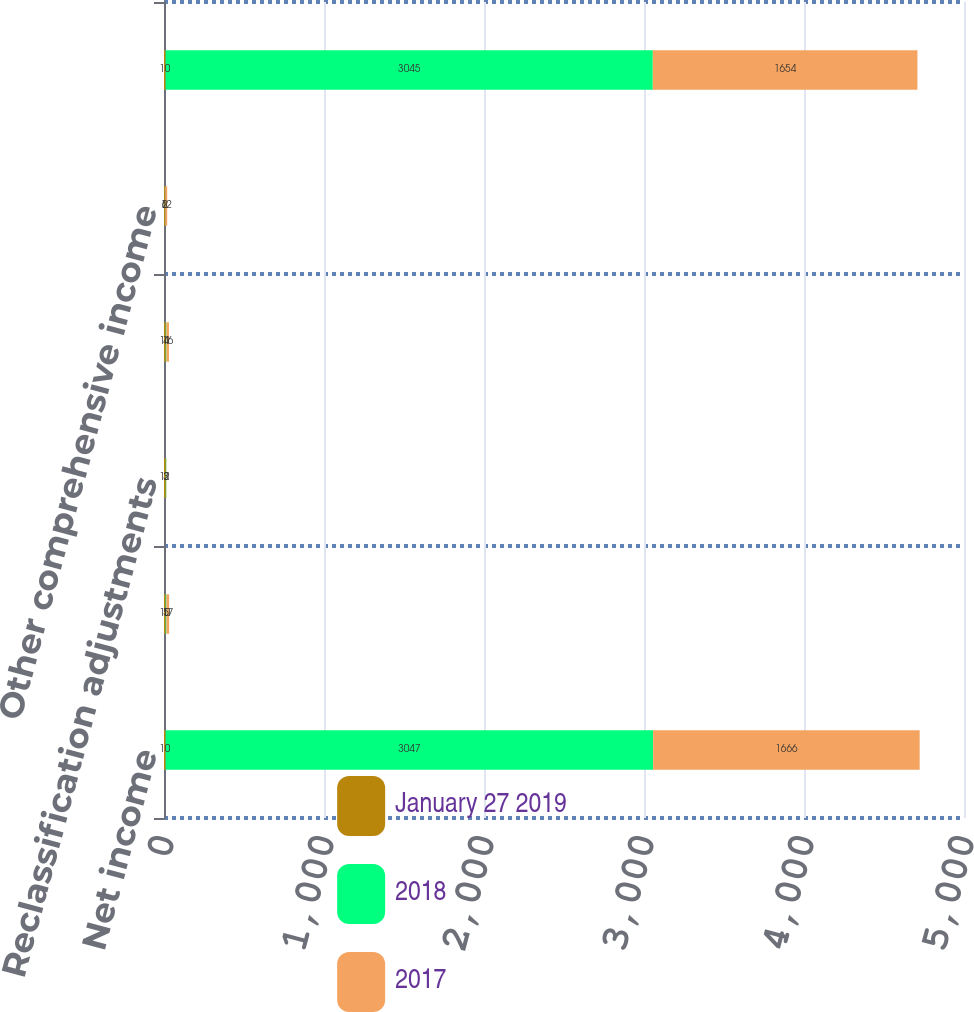Convert chart. <chart><loc_0><loc_0><loc_500><loc_500><stacked_bar_chart><ecel><fcel>Net income<fcel>Net unrealized gain (loss)<fcel>Reclassification adjustments<fcel>Net change in unrealized gain<fcel>Other comprehensive income<fcel>Total comprehensive income<nl><fcel>January 27 2019<fcel>10<fcel>10<fcel>11<fcel>11<fcel>6<fcel>10<nl><fcel>2018<fcel>3047<fcel>5<fcel>3<fcel>4<fcel>2<fcel>3045<nl><fcel>2017<fcel>1666<fcel>17<fcel>2<fcel>16<fcel>12<fcel>1654<nl></chart> 